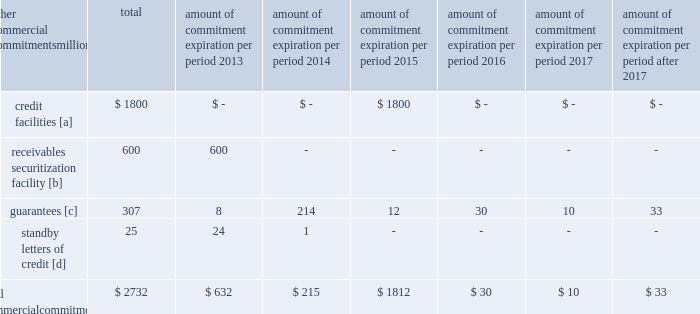Amount of commitment expiration per period other commercial commitments after millions total 2013 2014 2015 2016 2017 2017 .
[a] none of the credit facility was used as of december 31 , 2012 .
[b] $ 100 million of the receivables securitization facility was utilized at december 31 , 2012 , which is accounted for as debt .
The full program matures in july 2013 .
[c] includes guaranteed obligations related to our headquarters building , equipment financings , and affiliated operations .
[d] none of the letters of credit were drawn upon as of december 31 , 2012 .
Off-balance sheet arrangements guarantees 2013 at december 31 , 2012 , we were contingently liable for $ 307 million in guarantees .
We have recorded a liability of $ 2 million for the fair value of these obligations as of december 31 , 2012 and 2011 .
We entered into these contingent guarantees in the normal course of business , and they include guaranteed obligations related to our headquarters building , equipment financings , and affiliated operations .
The final guarantee expires in 2022 .
We are not aware of any existing event of default that would require us to satisfy these guarantees .
We do not expect that these guarantees will have a material adverse effect on our consolidated financial condition , results of operations , or liquidity .
Other matters labor agreements 2013 approximately 86% ( 86 % ) of our 45928 full-time-equivalent employees are represented by 14 major rail unions .
During the year , we concluded the most recent round of negotiations , which began in 2010 , with the ratification of new agreements by several unions that continued negotiating into 2012 .
All of the unions executed similar multi-year agreements that provide for higher employee cost sharing of employee health and welfare benefits and higher wages .
The current agreements will remain in effect until renegotiated under provisions of the railway labor act .
The next round of negotiations will begin in early 2015 .
Inflation 2013 long periods of inflation significantly increase asset replacement costs for capital-intensive companies .
As a result , assuming that we replace all operating assets at current price levels , depreciation charges ( on an inflation-adjusted basis ) would be substantially greater than historically reported amounts .
Derivative financial instruments 2013 we may use derivative financial instruments in limited instances to assist in managing our overall exposure to fluctuations in interest rates and fuel prices .
We are not a party to leveraged derivatives and , by policy , do not use derivative financial instruments for speculative purposes .
Derivative financial instruments qualifying for hedge accounting must maintain a specified level of effectiveness between the hedging instrument and the item being hedged , both at inception and throughout the hedged period .
We formally document the nature and relationships between the hedging instruments and hedged items at inception , as well as our risk-management objectives , strategies for undertaking the various hedge transactions , and method of assessing hedge effectiveness .
Changes in the fair market value of derivative financial instruments that do not qualify for hedge accounting are charged to earnings .
We may use swaps , collars , futures , and/or forward contracts to mitigate the risk of adverse movements in interest rates and fuel prices ; however , the use of these derivative financial instruments may limit future benefits from favorable price movements .
Market and credit risk 2013 we address market risk related to derivative financial instruments by selecting instruments with value fluctuations that highly correlate with the underlying hedged item .
We manage credit risk related to derivative financial instruments , which is minimal , by requiring high credit standards for counterparties and periodic settlements .
At december 31 , 2012 and 2011 , we were not required to provide collateral , nor had we received collateral , relating to our hedging activities. .
What portion of the standby letters of credit are current? 
Rationale: current is due in the next 12 months
Computations: (24 / 25)
Answer: 0.96. Amount of commitment expiration per period other commercial commitments after millions total 2013 2014 2015 2016 2017 2017 .
[a] none of the credit facility was used as of december 31 , 2012 .
[b] $ 100 million of the receivables securitization facility was utilized at december 31 , 2012 , which is accounted for as debt .
The full program matures in july 2013 .
[c] includes guaranteed obligations related to our headquarters building , equipment financings , and affiliated operations .
[d] none of the letters of credit were drawn upon as of december 31 , 2012 .
Off-balance sheet arrangements guarantees 2013 at december 31 , 2012 , we were contingently liable for $ 307 million in guarantees .
We have recorded a liability of $ 2 million for the fair value of these obligations as of december 31 , 2012 and 2011 .
We entered into these contingent guarantees in the normal course of business , and they include guaranteed obligations related to our headquarters building , equipment financings , and affiliated operations .
The final guarantee expires in 2022 .
We are not aware of any existing event of default that would require us to satisfy these guarantees .
We do not expect that these guarantees will have a material adverse effect on our consolidated financial condition , results of operations , or liquidity .
Other matters labor agreements 2013 approximately 86% ( 86 % ) of our 45928 full-time-equivalent employees are represented by 14 major rail unions .
During the year , we concluded the most recent round of negotiations , which began in 2010 , with the ratification of new agreements by several unions that continued negotiating into 2012 .
All of the unions executed similar multi-year agreements that provide for higher employee cost sharing of employee health and welfare benefits and higher wages .
The current agreements will remain in effect until renegotiated under provisions of the railway labor act .
The next round of negotiations will begin in early 2015 .
Inflation 2013 long periods of inflation significantly increase asset replacement costs for capital-intensive companies .
As a result , assuming that we replace all operating assets at current price levels , depreciation charges ( on an inflation-adjusted basis ) would be substantially greater than historically reported amounts .
Derivative financial instruments 2013 we may use derivative financial instruments in limited instances to assist in managing our overall exposure to fluctuations in interest rates and fuel prices .
We are not a party to leveraged derivatives and , by policy , do not use derivative financial instruments for speculative purposes .
Derivative financial instruments qualifying for hedge accounting must maintain a specified level of effectiveness between the hedging instrument and the item being hedged , both at inception and throughout the hedged period .
We formally document the nature and relationships between the hedging instruments and hedged items at inception , as well as our risk-management objectives , strategies for undertaking the various hedge transactions , and method of assessing hedge effectiveness .
Changes in the fair market value of derivative financial instruments that do not qualify for hedge accounting are charged to earnings .
We may use swaps , collars , futures , and/or forward contracts to mitigate the risk of adverse movements in interest rates and fuel prices ; however , the use of these derivative financial instruments may limit future benefits from favorable price movements .
Market and credit risk 2013 we address market risk related to derivative financial instruments by selecting instruments with value fluctuations that highly correlate with the underlying hedged item .
We manage credit risk related to derivative financial instruments , which is minimal , by requiring high credit standards for counterparties and periodic settlements .
At december 31 , 2012 and 2011 , we were not required to provide collateral , nor had we received collateral , relating to our hedging activities. .
What percentage of total commercial commitments are receivables securitization facility? 
Computations: (600 / 2732)
Answer: 0.21962. 